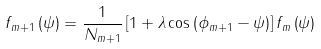Convert formula to latex. <formula><loc_0><loc_0><loc_500><loc_500>f _ { m + 1 } \left ( \psi \right ) = \frac { 1 } { N _ { m + 1 } } \left [ 1 + \lambda \cos \left ( \phi _ { m + 1 } - \psi \right ) \right ] f _ { m } \left ( \psi \right )</formula> 